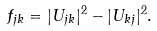<formula> <loc_0><loc_0><loc_500><loc_500>f _ { j k } = | U _ { j k } | ^ { 2 } - | U _ { k j } | ^ { 2 } .</formula> 